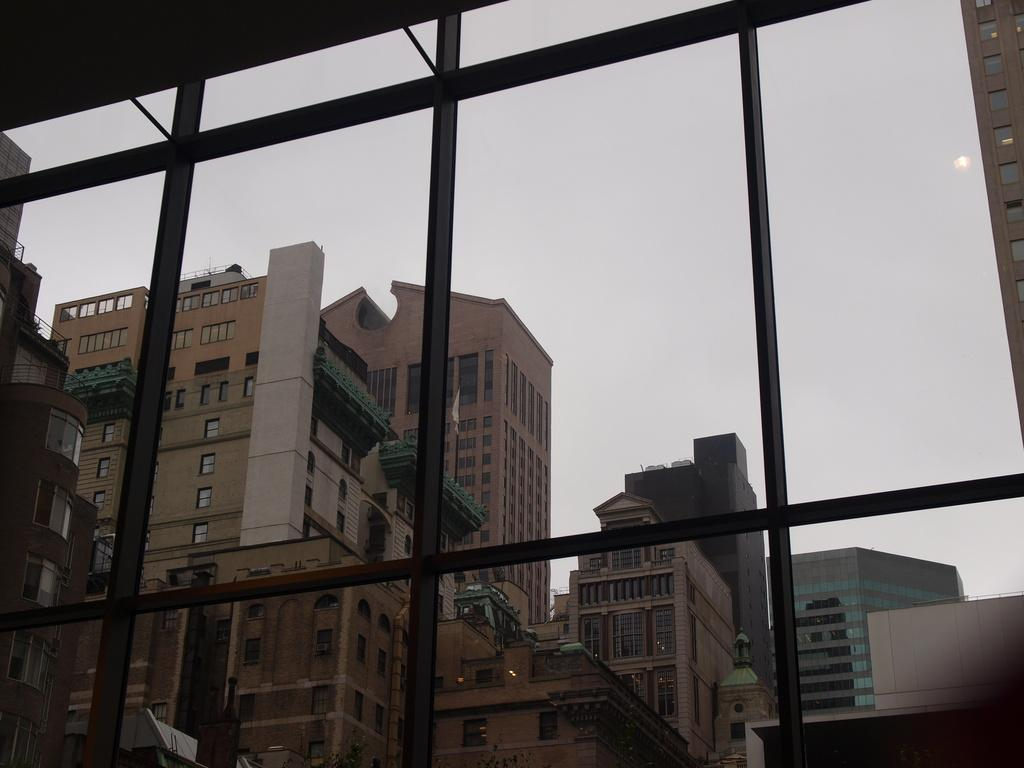What is located in the foreground of the image? There is a window in the foreground of the image. What is associated with the window? There are grills associated with the window. What can be seen through the window? Buildings and houses are visible through the window. What is visible at the top of the image? The sky is visible at the top of the image. Can you see any fairies dancing on the stage through the window in the image? There is no stage or fairies present in the image; it only features a window with grills and a view of buildings and houses. 